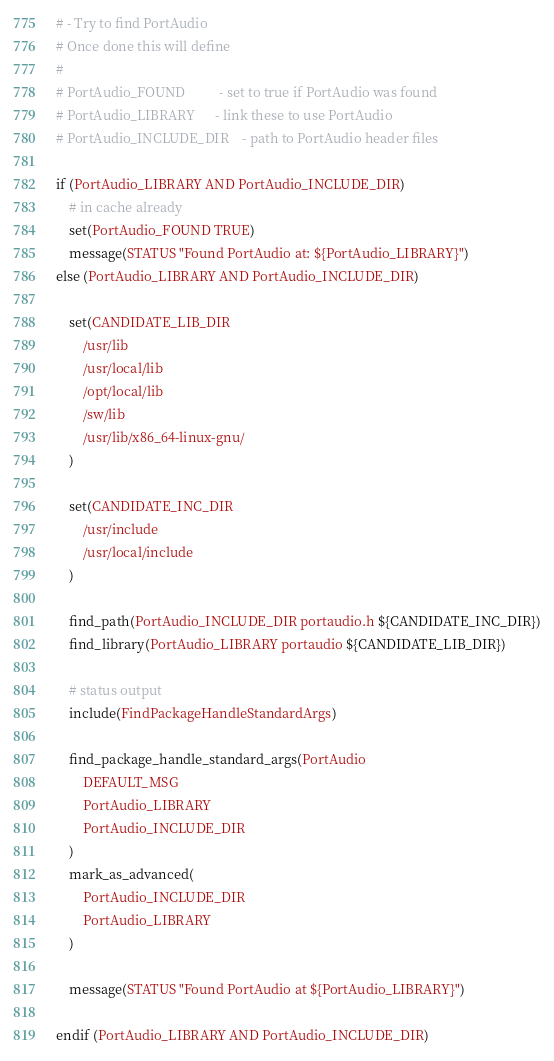Convert code to text. <code><loc_0><loc_0><loc_500><loc_500><_CMake_># - Try to find PortAudio
# Once done this will define
#
# PortAudio_FOUND          - set to true if PortAudio was found
# PortAudio_LIBRARY      - link these to use PortAudio
# PortAudio_INCLUDE_DIR    - path to PortAudio header files

if (PortAudio_LIBRARY AND PortAudio_INCLUDE_DIR)
	# in cache already
	set(PortAudio_FOUND TRUE)
	message(STATUS "Found PortAudio at: ${PortAudio_LIBRARY}")
else (PortAudio_LIBRARY AND PortAudio_INCLUDE_DIR)

	set(CANDIDATE_LIB_DIR
		/usr/lib
		/usr/local/lib
		/opt/local/lib
		/sw/lib
		/usr/lib/x86_64-linux-gnu/
	)

	set(CANDIDATE_INC_DIR
		/usr/include
		/usr/local/include
	)

	find_path(PortAudio_INCLUDE_DIR portaudio.h ${CANDIDATE_INC_DIR})
	find_library(PortAudio_LIBRARY portaudio ${CANDIDATE_LIB_DIR})

	# status output
	include(FindPackageHandleStandardArgs)

	find_package_handle_standard_args(PortAudio
		DEFAULT_MSG
		PortAudio_LIBRARY
		PortAudio_INCLUDE_DIR
	)
	mark_as_advanced(
		PortAudio_INCLUDE_DIR
		PortAudio_LIBRARY
	)

	message(STATUS "Found PortAudio at ${PortAudio_LIBRARY}")

endif (PortAudio_LIBRARY AND PortAudio_INCLUDE_DIR)
</code> 